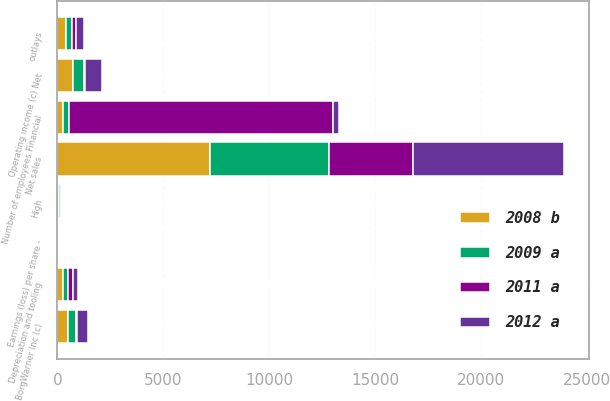Convert chart to OTSL. <chart><loc_0><loc_0><loc_500><loc_500><stacked_bar_chart><ecel><fcel>Net sales<fcel>Operating income (c) Net<fcel>BorgWarner Inc (c)<fcel>Earnings (loss) per share -<fcel>outlays<fcel>Depreciation and tooling<fcel>Number of employees Financial<fcel>High<nl><fcel>2008 b<fcel>7183.2<fcel>752.9<fcel>500.9<fcel>4.45<fcel>407.4<fcel>260.2<fcel>260.2<fcel>87.45<nl><fcel>2012 a<fcel>7114.7<fcel>797.5<fcel>550.1<fcel>5.04<fcel>393.7<fcel>252.2<fcel>260.2<fcel>82.28<nl><fcel>2009 a<fcel>5652.8<fcel>504.3<fcel>377.4<fcel>3.31<fcel>276.6<fcel>224.5<fcel>260.2<fcel>73.43<nl><fcel>2011 a<fcel>3961.8<fcel>50.8<fcel>27<fcel>0.23<fcel>172<fcel>234.6<fcel>12500<fcel>36.78<nl></chart> 